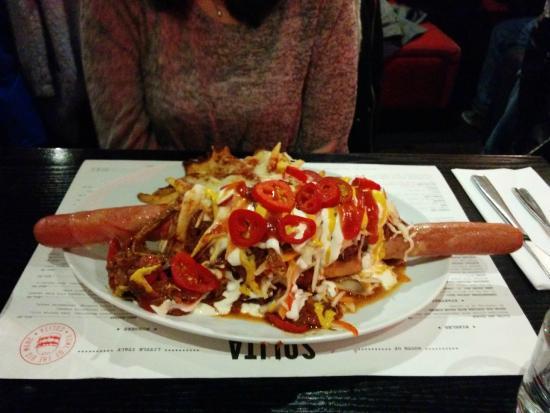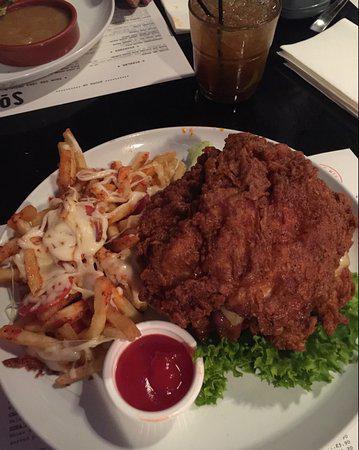The first image is the image on the left, the second image is the image on the right. Evaluate the accuracy of this statement regarding the images: "At least one burger is shown on a plate with some pizza fries.". Is it true? Answer yes or no. No. The first image is the image on the left, the second image is the image on the right. Assess this claim about the two images: "In at least one image there is a white plate with pizza fries and a burger next to ketchup.". Correct or not? Answer yes or no. No. 